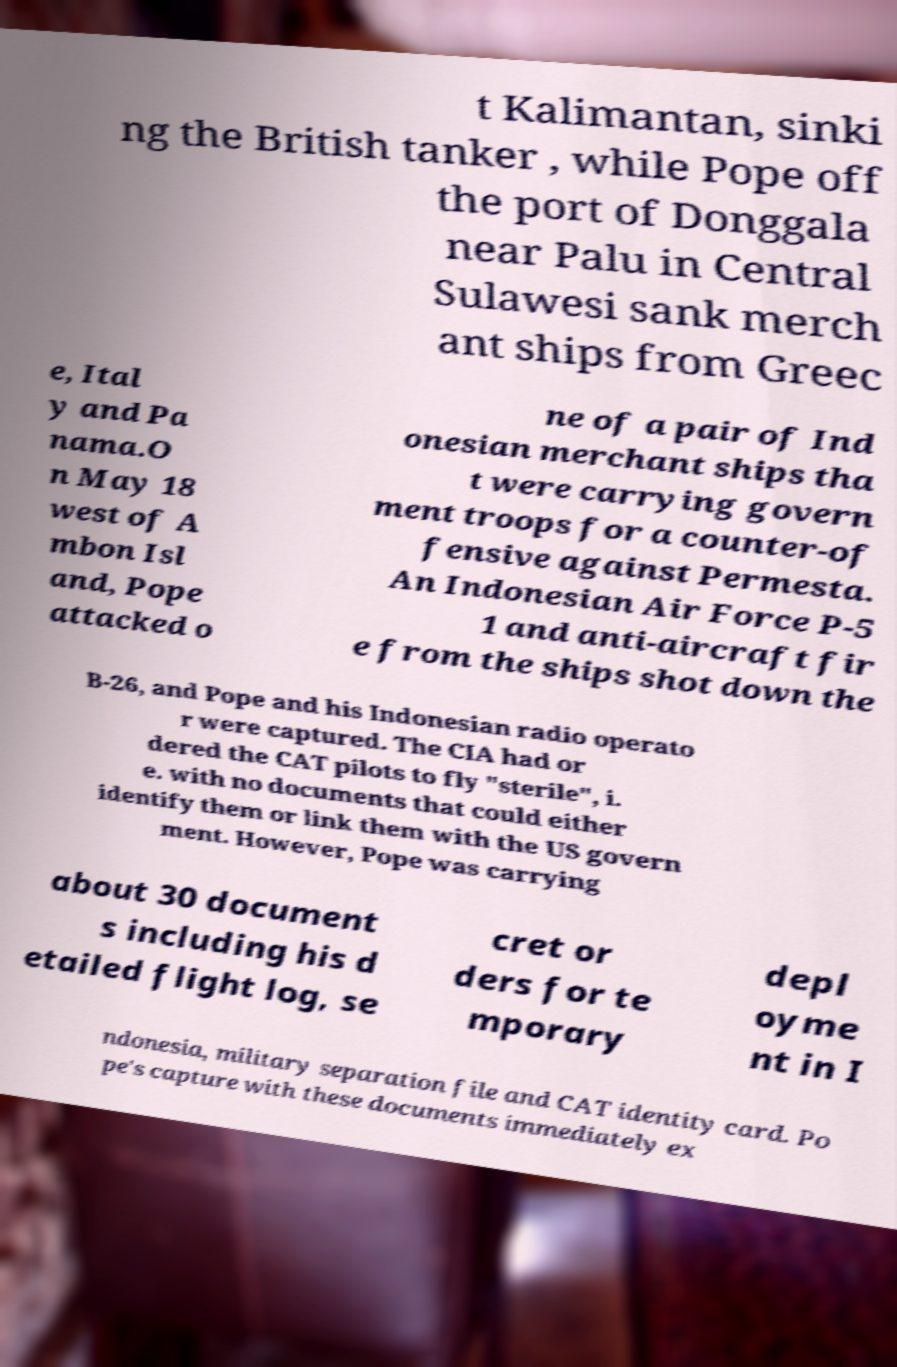There's text embedded in this image that I need extracted. Can you transcribe it verbatim? t Kalimantan, sinki ng the British tanker , while Pope off the port of Donggala near Palu in Central Sulawesi sank merch ant ships from Greec e, Ital y and Pa nama.O n May 18 west of A mbon Isl and, Pope attacked o ne of a pair of Ind onesian merchant ships tha t were carrying govern ment troops for a counter-of fensive against Permesta. An Indonesian Air Force P-5 1 and anti-aircraft fir e from the ships shot down the B-26, and Pope and his Indonesian radio operato r were captured. The CIA had or dered the CAT pilots to fly "sterile", i. e. with no documents that could either identify them or link them with the US govern ment. However, Pope was carrying about 30 document s including his d etailed flight log, se cret or ders for te mporary depl oyme nt in I ndonesia, military separation file and CAT identity card. Po pe's capture with these documents immediately ex 